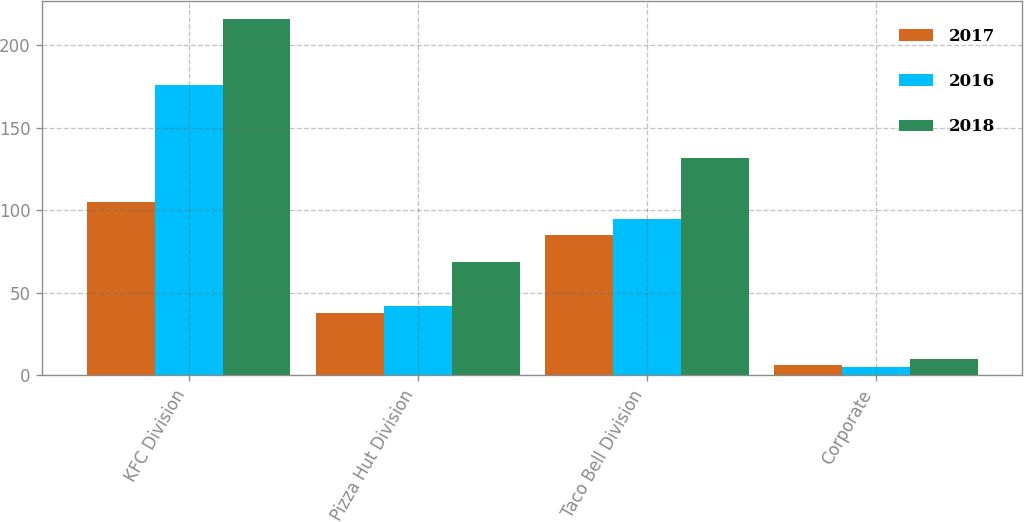Convert chart. <chart><loc_0><loc_0><loc_500><loc_500><stacked_bar_chart><ecel><fcel>KFC Division<fcel>Pizza Hut Division<fcel>Taco Bell Division<fcel>Corporate<nl><fcel>2017<fcel>105<fcel>38<fcel>85<fcel>6<nl><fcel>2016<fcel>176<fcel>42<fcel>95<fcel>5<nl><fcel>2018<fcel>216<fcel>69<fcel>132<fcel>10<nl></chart> 